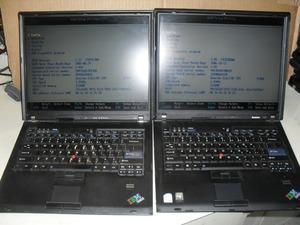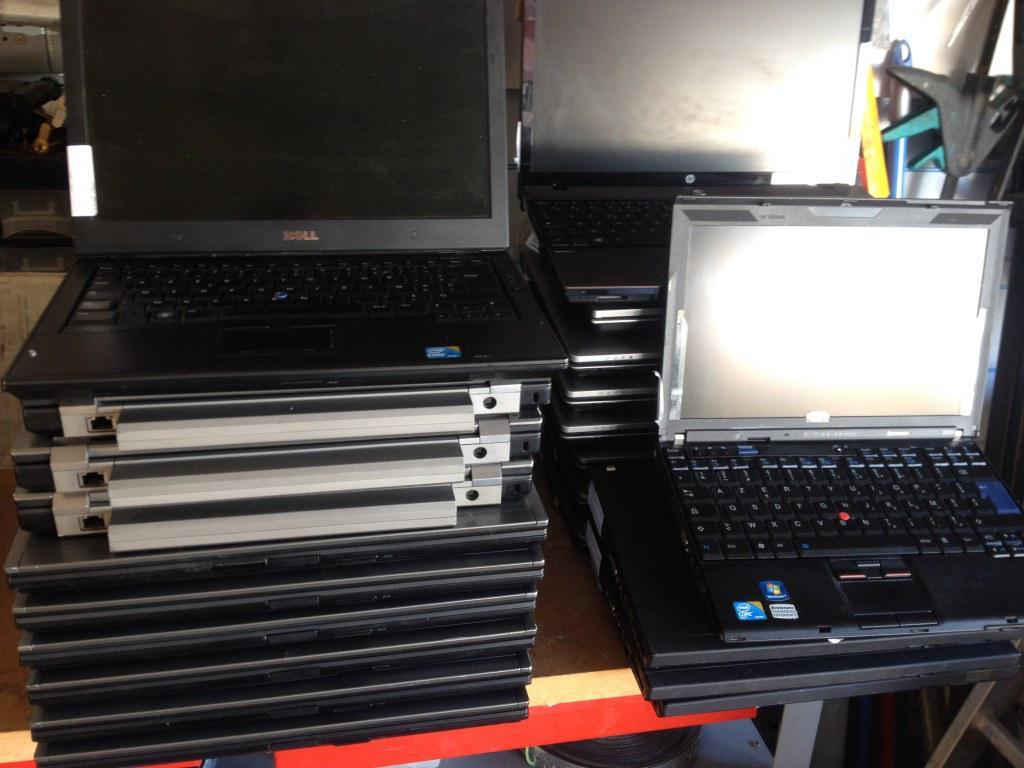The first image is the image on the left, the second image is the image on the right. Analyze the images presented: Is the assertion "The left image shows laptops in horizontal rows of three and includes rows of open laptops and rows of closed laptops." valid? Answer yes or no. No. The first image is the image on the left, the second image is the image on the right. Considering the images on both sides, is "There are exactly five open laptops." valid? Answer yes or no. Yes. 